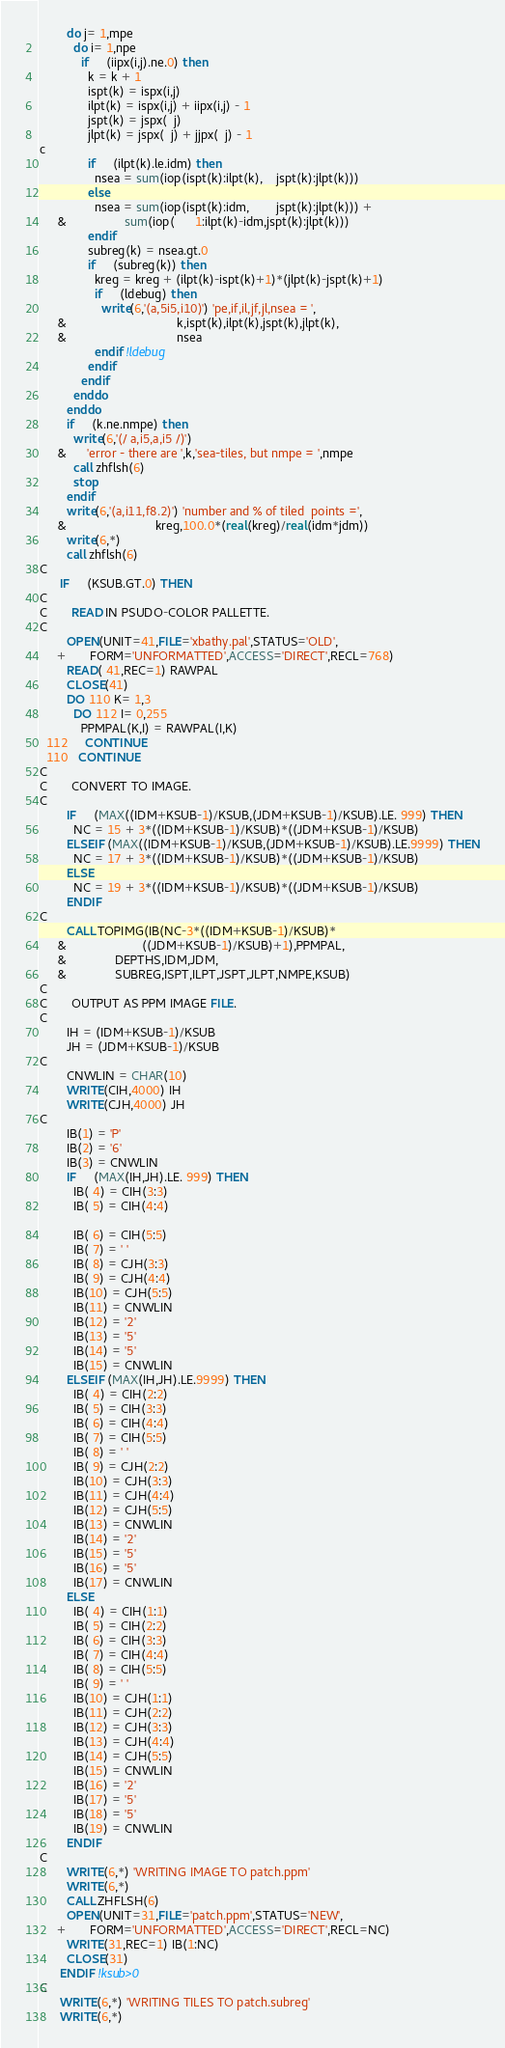<code> <loc_0><loc_0><loc_500><loc_500><_FORTRAN_>        do j= 1,mpe
          do i= 1,npe
            if     (iipx(i,j).ne.0) then
              k = k + 1
              ispt(k) = ispx(i,j)
              ilpt(k) = ispx(i,j) + iipx(i,j) - 1
              jspt(k) = jspx(  j)
              jlpt(k) = jspx(  j) + jjpx(  j) - 1
c
              if     (ilpt(k).le.idm) then
                nsea = sum(iop(ispt(k):ilpt(k),    jspt(k):jlpt(k)))
              else
                nsea = sum(iop(ispt(k):idm,        jspt(k):jlpt(k))) +
     &                 sum(iop(      1:ilpt(k)-idm,jspt(k):jlpt(k)))
              endif
              subreg(k) = nsea.gt.0
              if     (subreg(k)) then
                kreg = kreg + (ilpt(k)-ispt(k)+1)*(jlpt(k)-jspt(k)+1)
                if     (ldebug) then
                  write(6,'(a,5i5,i10)') 'pe,if,il,jf,jl,nsea = ',
     &                                k,ispt(k),ilpt(k),jspt(k),jlpt(k),
     &                                nsea
                endif !ldebug
              endif
            endif
          enddo
        enddo
        if     (k.ne.nmpe) then
          write(6,'(/ a,i5,a,i5 /)')
     &      'error - there are ',k,'sea-tiles, but nmpe = ',nmpe
          call zhflsh(6)
          stop
        endif
        write(6,'(a,i11,f8.2)') 'number and % of tiled  points =',
     &                          kreg,100.0*(real(kreg)/real(idm*jdm))
        write(6,*)
        call zhflsh(6)
C
      IF     (KSUB.GT.0) THEN
C
C       READ IN PSUDO-COLOR PALLETTE.
C
        OPEN(UNIT=41,FILE='xbathy.pal',STATUS='OLD',
     +       FORM='UNFORMATTED',ACCESS='DIRECT',RECL=768)
        READ( 41,REC=1) RAWPAL
        CLOSE(41)
        DO 110 K= 1,3
          DO 112 I= 0,255
            PPMPAL(K,I) = RAWPAL(I,K)
  112     CONTINUE
  110   CONTINUE
C
C       CONVERT TO IMAGE.
C
        IF     (MAX((IDM+KSUB-1)/KSUB,(JDM+KSUB-1)/KSUB).LE. 999) THEN
          NC = 15 + 3*((IDM+KSUB-1)/KSUB)*((JDM+KSUB-1)/KSUB)
        ELSEIF (MAX((IDM+KSUB-1)/KSUB,(JDM+KSUB-1)/KSUB).LE.9999) THEN
          NC = 17 + 3*((IDM+KSUB-1)/KSUB)*((JDM+KSUB-1)/KSUB)
        ELSE
          NC = 19 + 3*((IDM+KSUB-1)/KSUB)*((JDM+KSUB-1)/KSUB)
        ENDIF
C
        CALL TOPIMG(IB(NC-3*((IDM+KSUB-1)/KSUB)*
     &                      ((JDM+KSUB-1)/KSUB)+1),PPMPAL,
     &              DEPTHS,IDM,JDM,
     &              SUBREG,ISPT,ILPT,JSPT,JLPT,NMPE,KSUB)
C
C       OUTPUT AS PPM IMAGE FILE.
C
        IH = (IDM+KSUB-1)/KSUB
        JH = (JDM+KSUB-1)/KSUB
C
        CNWLIN = CHAR(10)
        WRITE(CIH,4000) IH
        WRITE(CJH,4000) JH
C
        IB(1) = 'P'
        IB(2) = '6'
        IB(3) = CNWLIN
        IF     (MAX(IH,JH).LE. 999) THEN
          IB( 4) = CIH(3:3)
          IB( 5) = CIH(4:4)

          IB( 6) = CIH(5:5)
          IB( 7) = ' '
          IB( 8) = CJH(3:3)
          IB( 9) = CJH(4:4)
          IB(10) = CJH(5:5)
          IB(11) = CNWLIN
          IB(12) = '2'
          IB(13) = '5'
          IB(14) = '5'
          IB(15) = CNWLIN
        ELSEIF (MAX(IH,JH).LE.9999) THEN
          IB( 4) = CIH(2:2)
          IB( 5) = CIH(3:3)
          IB( 6) = CIH(4:4)
          IB( 7) = CIH(5:5)
          IB( 8) = ' '
          IB( 9) = CJH(2:2)
          IB(10) = CJH(3:3)
          IB(11) = CJH(4:4)
          IB(12) = CJH(5:5)
          IB(13) = CNWLIN
          IB(14) = '2'
          IB(15) = '5'
          IB(16) = '5'
          IB(17) = CNWLIN
        ELSE
          IB( 4) = CIH(1:1)
          IB( 5) = CIH(2:2)
          IB( 6) = CIH(3:3)
          IB( 7) = CIH(4:4)
          IB( 8) = CIH(5:5)
          IB( 9) = ' '
          IB(10) = CJH(1:1)
          IB(11) = CJH(2:2)
          IB(12) = CJH(3:3)
          IB(13) = CJH(4:4)
          IB(14) = CJH(5:5)
          IB(15) = CNWLIN
          IB(16) = '2'
          IB(17) = '5'
          IB(18) = '5'
          IB(19) = CNWLIN
        ENDIF
C
        WRITE(6,*) 'WRITING IMAGE TO patch.ppm'
        WRITE(6,*)
        CALL ZHFLSH(6)
        OPEN(UNIT=31,FILE='patch.ppm',STATUS='NEW',
     +       FORM='UNFORMATTED',ACCESS='DIRECT',RECL=NC)
        WRITE(31,REC=1) IB(1:NC)
        CLOSE(31)
      ENDIF !ksub>0
C
      WRITE(6,*) 'WRITING TILES TO patch.subreg'
      WRITE(6,*)</code> 